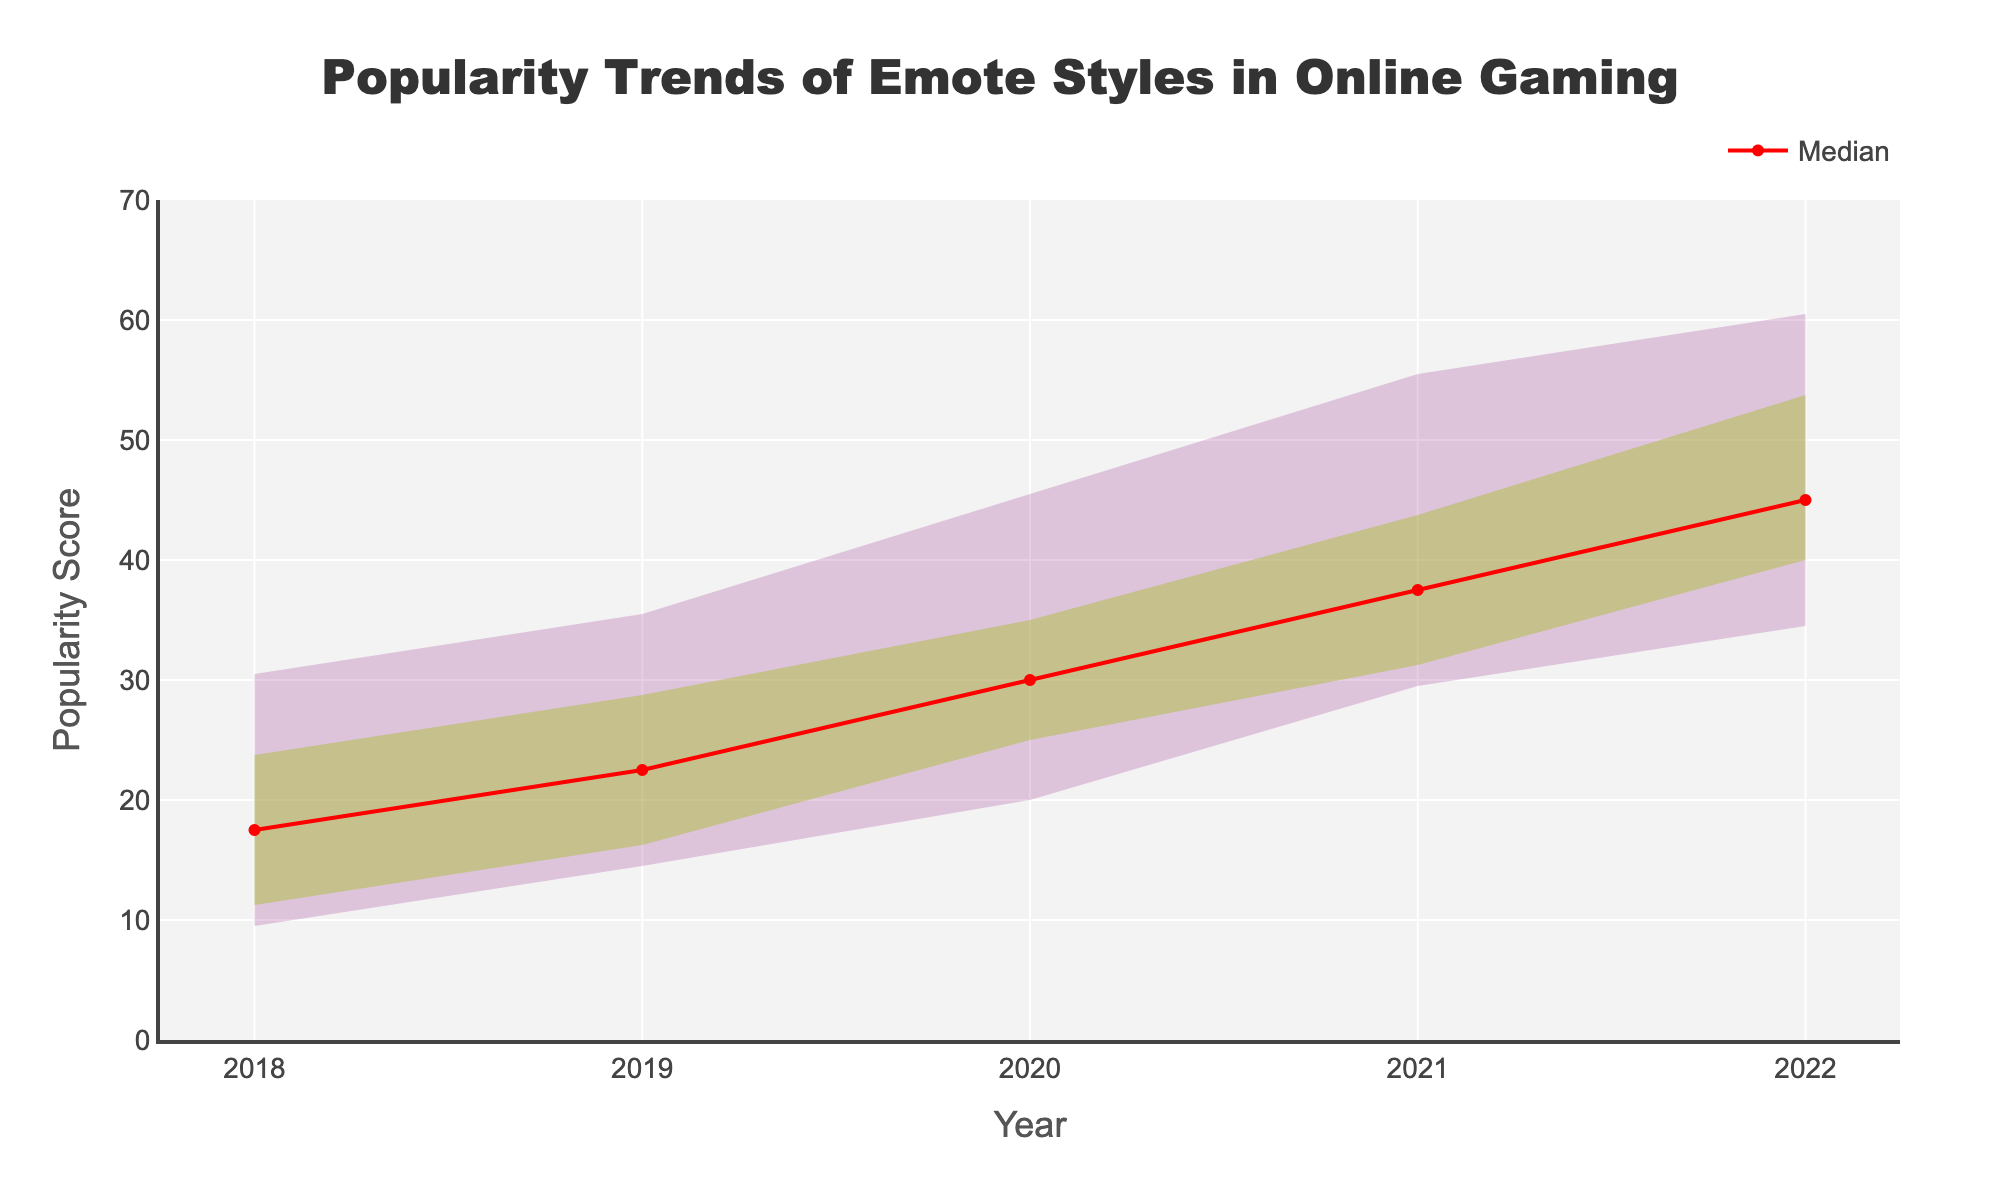What is the title of the figure? The title is usually located at the top of the figure, indicating the main topic or focus. In this case, it reads 'Popularity Trends of Emote Styles in Online Gaming'.
Answer: Popularity Trends of Emote Styles in Online Gaming How many years of data are presented in the figure? The x-axis of the figure shows the years for which data have been collected. By counting these tick marks, we determine the number of years.
Answer: 5 Which emote style had the highest median popularity in 2022? To find the highest median popularity in 2022, look at the y-values of the red median line for each emote style at the 2022 datapoint on the x-axis.
Answer: Meme-based What is the range of popularity scores in 2020 for all emote styles? The range is the difference between the highest and lowest popularity scores. The filled areas indicate the spread of the score percentiles. For 2020, the range is calculated by finding the highest 90th percentile and the lowest 10th percentile.
Answer: 55 Which percentile has the widest fan spread in 2019? The width of the fan spread is the distance between the corresponding percentiles. Look for the percentile with the greatest difference between its upper and lower bounds in 2019.
Answer: The 75th percentile In which year was the median popularity the highest? To find this, observe the red median line across all years and note the year where it reaches its highest value on the y-axis.
Answer: 2022 Compare the popularity trend of 3D Rendered and Pixel Art styles over 5 years. Which one had a more consistent increase? Consistency of increase can be evaluated by checking the gradient of the median lines over the 5 years. A steadier increase indicates more consistency.
Answer: Pixel Art What can be said about the popularity trend of the Chibi style from 2018 to 2022? To determine the trend, observe the slope of the lines representing the Chibi style's percentiles over the given years. An increasing slope indicates rising popularity.
Answer: Increasing What was the 90th percentile value for the Twitch-style emotes in 2021? Locate the 90th percentile trace and find its value at the 2021 mark on the x-axis.
Answer: 45 Which emote style showed the least increase in popularity from 2018 to 2022? Compare the starting and ending median values for each emote style over the given years and identify the smallest change.
Answer: Minimalist 